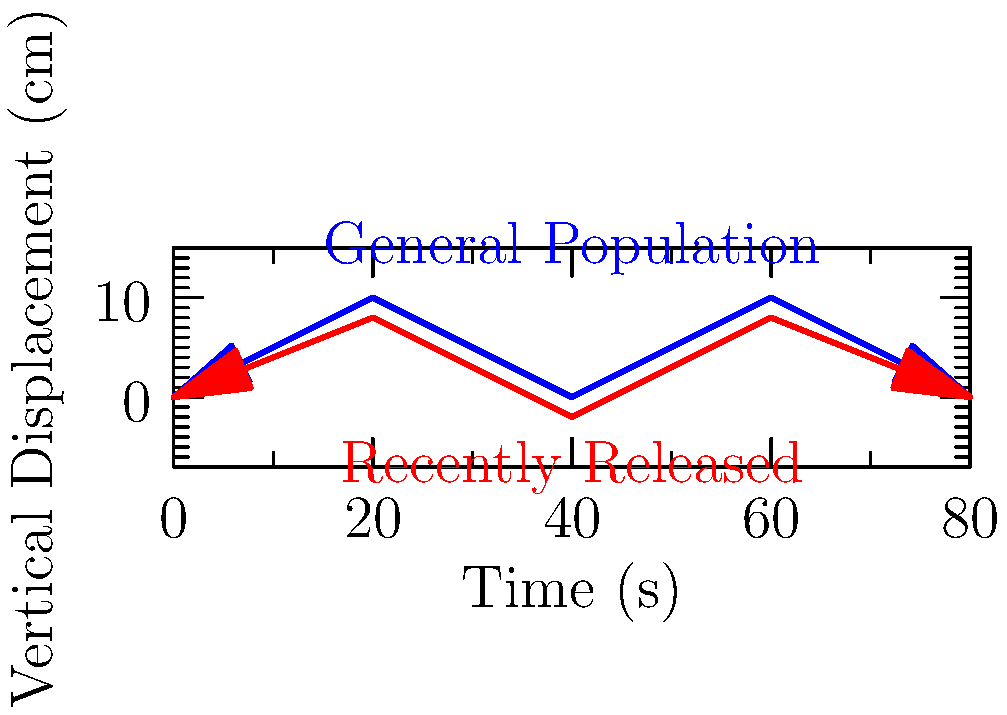Based on the motion capture diagram comparing gait patterns, what key biomechanical difference is observed between recently released individuals and the general population? To analyze the biomechanical differences in gait patterns between recently released individuals and the general population:

1. Observe the blue line representing the general population's gait pattern:
   - It shows a more pronounced up-and-down movement
   - The peaks and troughs are higher and lower, respectively

2. Examine the red line representing recently released individuals' gait pattern:
   - It displays a flatter trajectory
   - The peaks are lower and the troughs are not as deep

3. Compare the vertical displacement:
   - The general population's gait has a larger amplitude
   - Recently released individuals show reduced vertical displacement

4. Interpret the biomechanical implications:
   - Reduced vertical displacement suggests less push-off force during the gait cycle
   - This could indicate muscle weakness, reduced flexibility, or a cautious walking style

5. Consider potential causes:
   - Physical deconditioning during incarceration
   - Psychological factors affecting confidence in movement
   - Adaptation to confined spaces or specific walking patterns during incarceration

The key biomechanical difference is the reduced vertical displacement in the gait of recently released individuals, indicating a flatter, less dynamic walking pattern compared to the general population.
Answer: Reduced vertical displacement in gait 